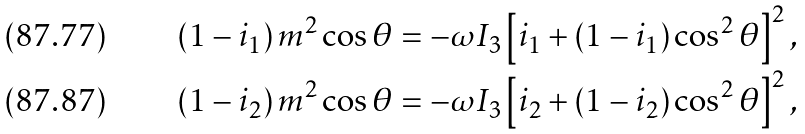<formula> <loc_0><loc_0><loc_500><loc_500>\left ( 1 - i _ { 1 } \right ) m ^ { 2 } \cos \theta & = - \omega I _ { 3 } \left [ i _ { 1 } + \left ( 1 - i _ { 1 } \right ) \cos ^ { 2 } \theta \right ] ^ { 2 } , \\ \left ( 1 - i _ { 2 } \right ) m ^ { 2 } \cos \theta & = - \omega I _ { 3 } \left [ i _ { 2 } + \left ( 1 - i _ { 2 } \right ) \cos ^ { 2 } \theta \right ] ^ { 2 } ,</formula> 